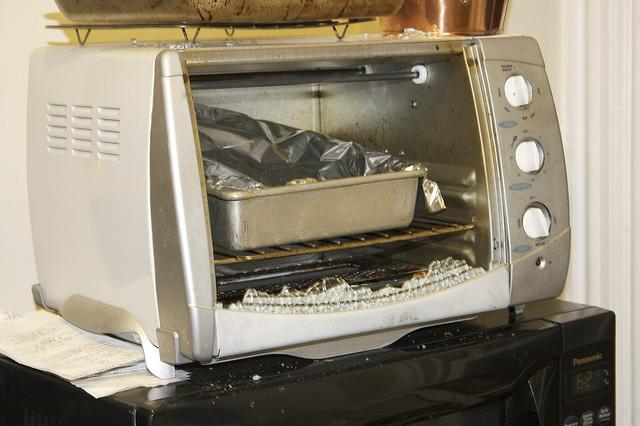What type of appliance is this?
Concise answer only. Toaster oven. Is the foil crumpled?
Concise answer only. Yes. How many white knobs are there?
Be succinct. 3. 